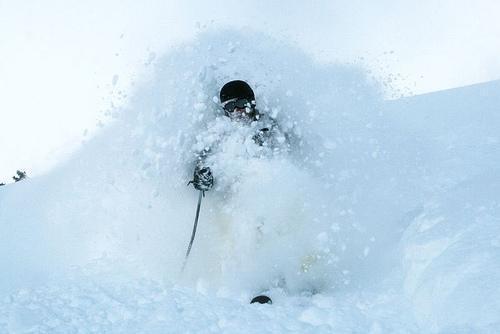How many people are in the picture?
Give a very brief answer. 1. 